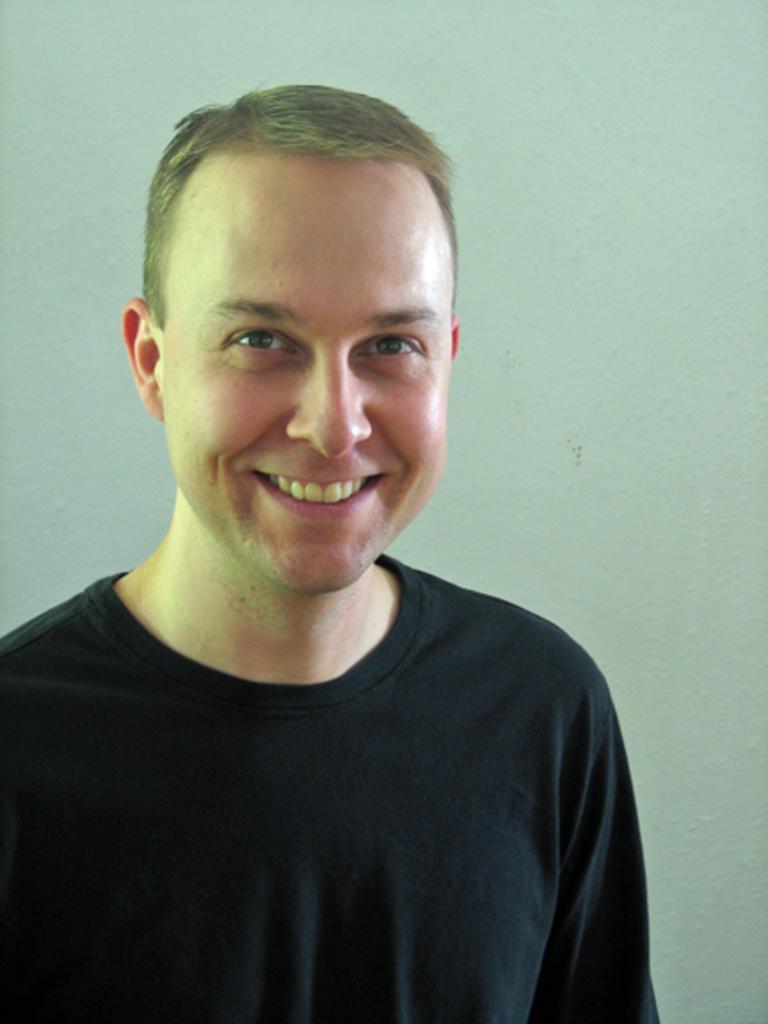Can you describe this image briefly? In the image there is a man in black t-shirt standing in front of wall and smiling. 